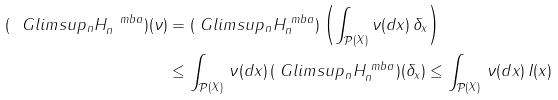<formula> <loc_0><loc_0><loc_500><loc_500>( \ G l i m s u p _ { n } H _ { n } ^ { \ m b a } ) ( \nu ) & = ( \ G l i m s u p _ { n } H _ { n } ^ { \ m b a } ) \left ( \int _ { \mathcal { P } ( X ) } \nu ( d x ) \, \delta _ { x } \right ) \\ & \leq \int _ { \mathcal { P } ( X ) } \, \nu ( d x ) \, ( \ G l i m s u p _ { n } H _ { n } ^ { \ m b a } ) ( \delta _ { x } ) \leq \int _ { \mathcal { P } ( X ) } \, \nu ( d x ) \, I ( x )</formula> 